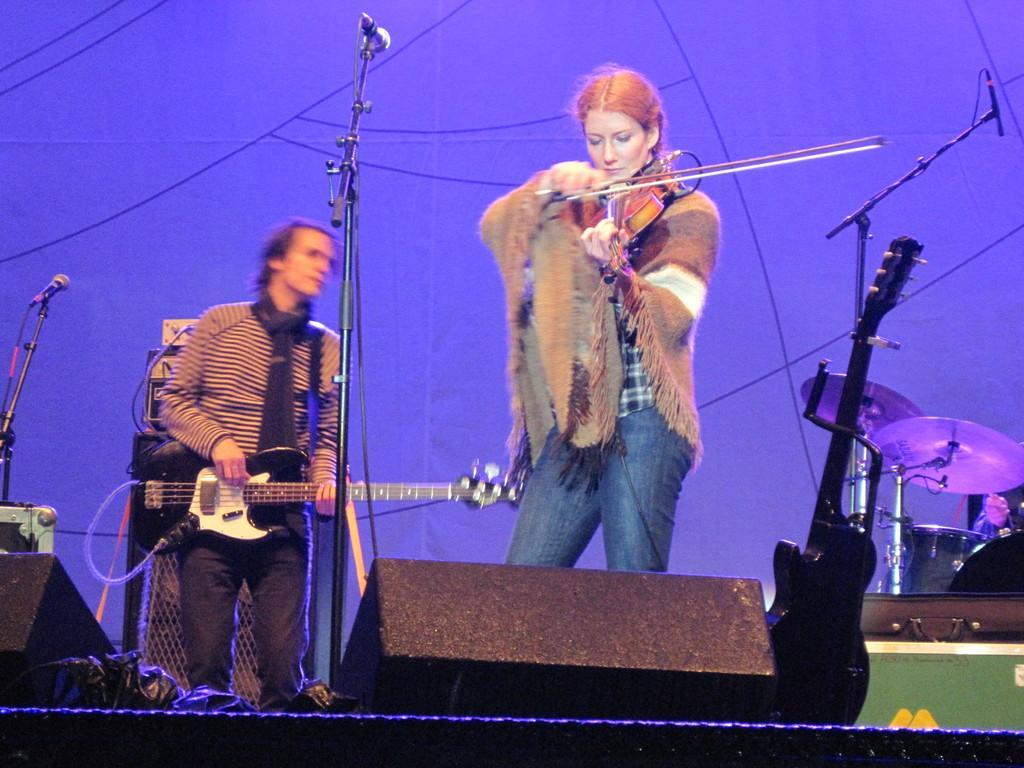In one or two sentences, can you explain what this image depicts? In this picture we can see two musicians, one man is playing guitar, and another woman is playing violin in front of microphone, in the background we can see couple of musical instruments and a speaker. 